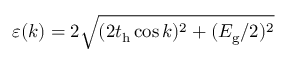Convert formula to latex. <formula><loc_0><loc_0><loc_500><loc_500>\varepsilon ( k ) = 2 \sqrt { ( 2 t _ { h } \cos k ) ^ { 2 } + ( E _ { g } / 2 ) ^ { 2 } }</formula> 